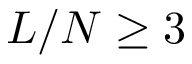<formula> <loc_0><loc_0><loc_500><loc_500>L / N \geq 3</formula> 